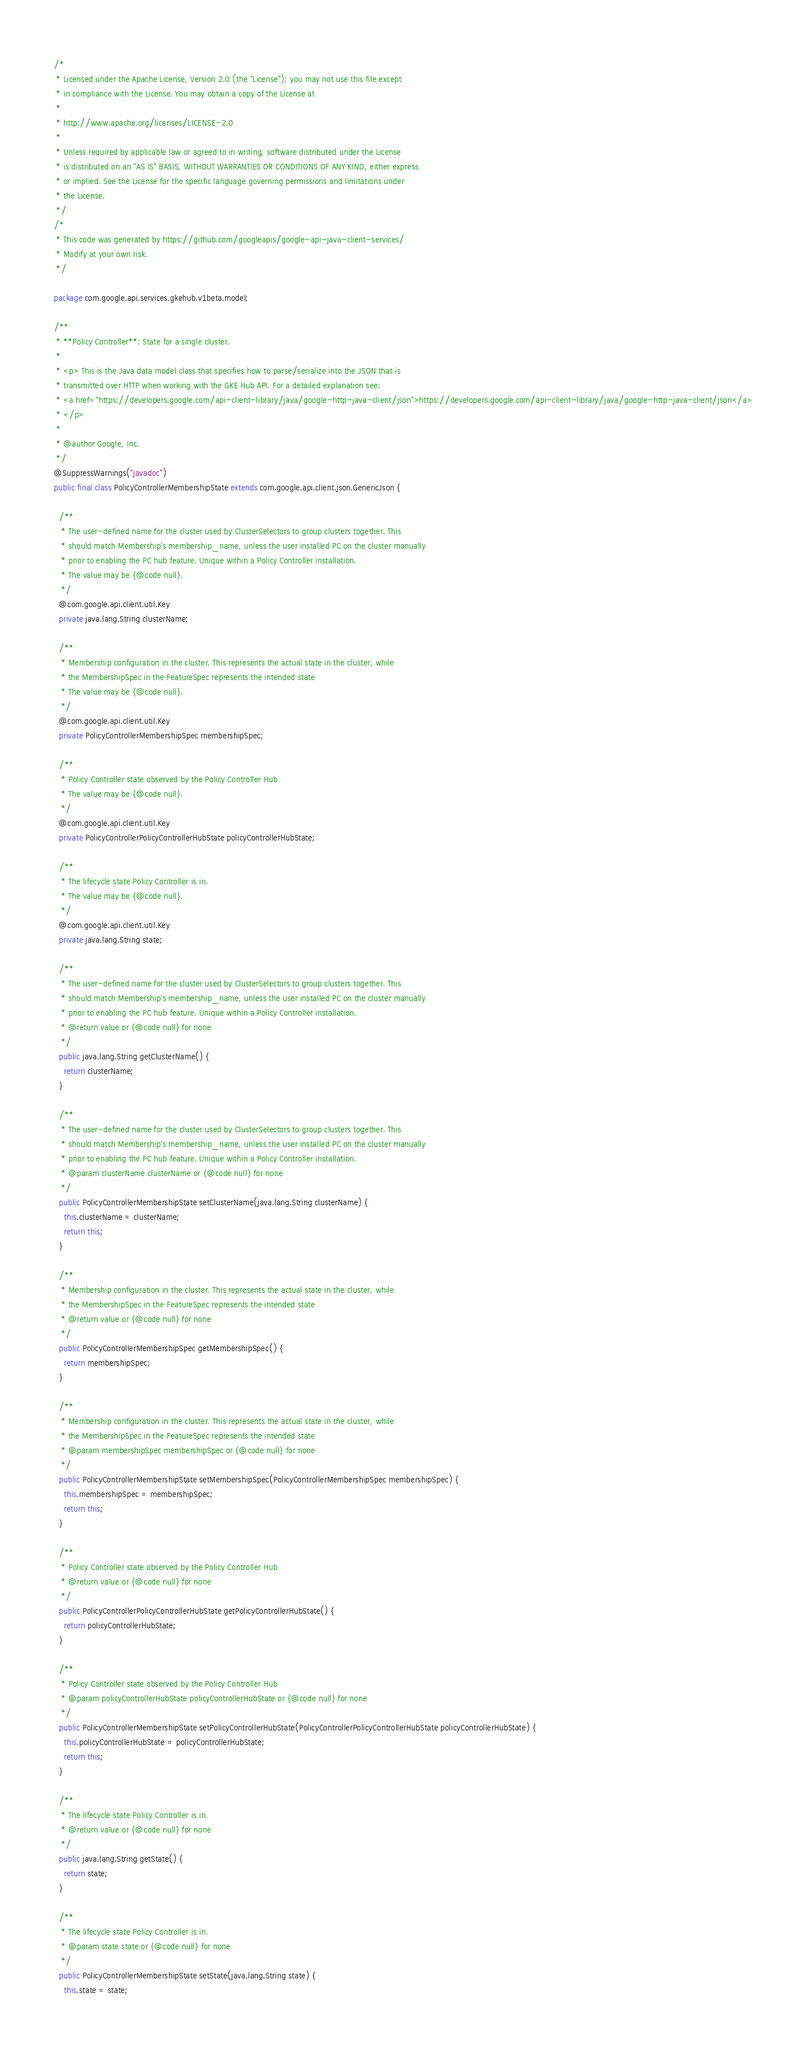Convert code to text. <code><loc_0><loc_0><loc_500><loc_500><_Java_>/*
 * Licensed under the Apache License, Version 2.0 (the "License"); you may not use this file except
 * in compliance with the License. You may obtain a copy of the License at
 *
 * http://www.apache.org/licenses/LICENSE-2.0
 *
 * Unless required by applicable law or agreed to in writing, software distributed under the License
 * is distributed on an "AS IS" BASIS, WITHOUT WARRANTIES OR CONDITIONS OF ANY KIND, either express
 * or implied. See the License for the specific language governing permissions and limitations under
 * the License.
 */
/*
 * This code was generated by https://github.com/googleapis/google-api-java-client-services/
 * Modify at your own risk.
 */

package com.google.api.services.gkehub.v1beta.model;

/**
 * **Policy Controller**: State for a single cluster.
 *
 * <p> This is the Java data model class that specifies how to parse/serialize into the JSON that is
 * transmitted over HTTP when working with the GKE Hub API. For a detailed explanation see:
 * <a href="https://developers.google.com/api-client-library/java/google-http-java-client/json">https://developers.google.com/api-client-library/java/google-http-java-client/json</a>
 * </p>
 *
 * @author Google, Inc.
 */
@SuppressWarnings("javadoc")
public final class PolicyControllerMembershipState extends com.google.api.client.json.GenericJson {

  /**
   * The user-defined name for the cluster used by ClusterSelectors to group clusters together. This
   * should match Membership's membership_name, unless the user installed PC on the cluster manually
   * prior to enabling the PC hub feature. Unique within a Policy Controller installation.
   * The value may be {@code null}.
   */
  @com.google.api.client.util.Key
  private java.lang.String clusterName;

  /**
   * Membership configuration in the cluster. This represents the actual state in the cluster, while
   * the MembershipSpec in the FeatureSpec represents the intended state
   * The value may be {@code null}.
   */
  @com.google.api.client.util.Key
  private PolicyControllerMembershipSpec membershipSpec;

  /**
   * Policy Controller state observed by the Policy Controller Hub
   * The value may be {@code null}.
   */
  @com.google.api.client.util.Key
  private PolicyControllerPolicyControllerHubState policyControllerHubState;

  /**
   * The lifecycle state Policy Controller is in.
   * The value may be {@code null}.
   */
  @com.google.api.client.util.Key
  private java.lang.String state;

  /**
   * The user-defined name for the cluster used by ClusterSelectors to group clusters together. This
   * should match Membership's membership_name, unless the user installed PC on the cluster manually
   * prior to enabling the PC hub feature. Unique within a Policy Controller installation.
   * @return value or {@code null} for none
   */
  public java.lang.String getClusterName() {
    return clusterName;
  }

  /**
   * The user-defined name for the cluster used by ClusterSelectors to group clusters together. This
   * should match Membership's membership_name, unless the user installed PC on the cluster manually
   * prior to enabling the PC hub feature. Unique within a Policy Controller installation.
   * @param clusterName clusterName or {@code null} for none
   */
  public PolicyControllerMembershipState setClusterName(java.lang.String clusterName) {
    this.clusterName = clusterName;
    return this;
  }

  /**
   * Membership configuration in the cluster. This represents the actual state in the cluster, while
   * the MembershipSpec in the FeatureSpec represents the intended state
   * @return value or {@code null} for none
   */
  public PolicyControllerMembershipSpec getMembershipSpec() {
    return membershipSpec;
  }

  /**
   * Membership configuration in the cluster. This represents the actual state in the cluster, while
   * the MembershipSpec in the FeatureSpec represents the intended state
   * @param membershipSpec membershipSpec or {@code null} for none
   */
  public PolicyControllerMembershipState setMembershipSpec(PolicyControllerMembershipSpec membershipSpec) {
    this.membershipSpec = membershipSpec;
    return this;
  }

  /**
   * Policy Controller state observed by the Policy Controller Hub
   * @return value or {@code null} for none
   */
  public PolicyControllerPolicyControllerHubState getPolicyControllerHubState() {
    return policyControllerHubState;
  }

  /**
   * Policy Controller state observed by the Policy Controller Hub
   * @param policyControllerHubState policyControllerHubState or {@code null} for none
   */
  public PolicyControllerMembershipState setPolicyControllerHubState(PolicyControllerPolicyControllerHubState policyControllerHubState) {
    this.policyControllerHubState = policyControllerHubState;
    return this;
  }

  /**
   * The lifecycle state Policy Controller is in.
   * @return value or {@code null} for none
   */
  public java.lang.String getState() {
    return state;
  }

  /**
   * The lifecycle state Policy Controller is in.
   * @param state state or {@code null} for none
   */
  public PolicyControllerMembershipState setState(java.lang.String state) {
    this.state = state;</code> 